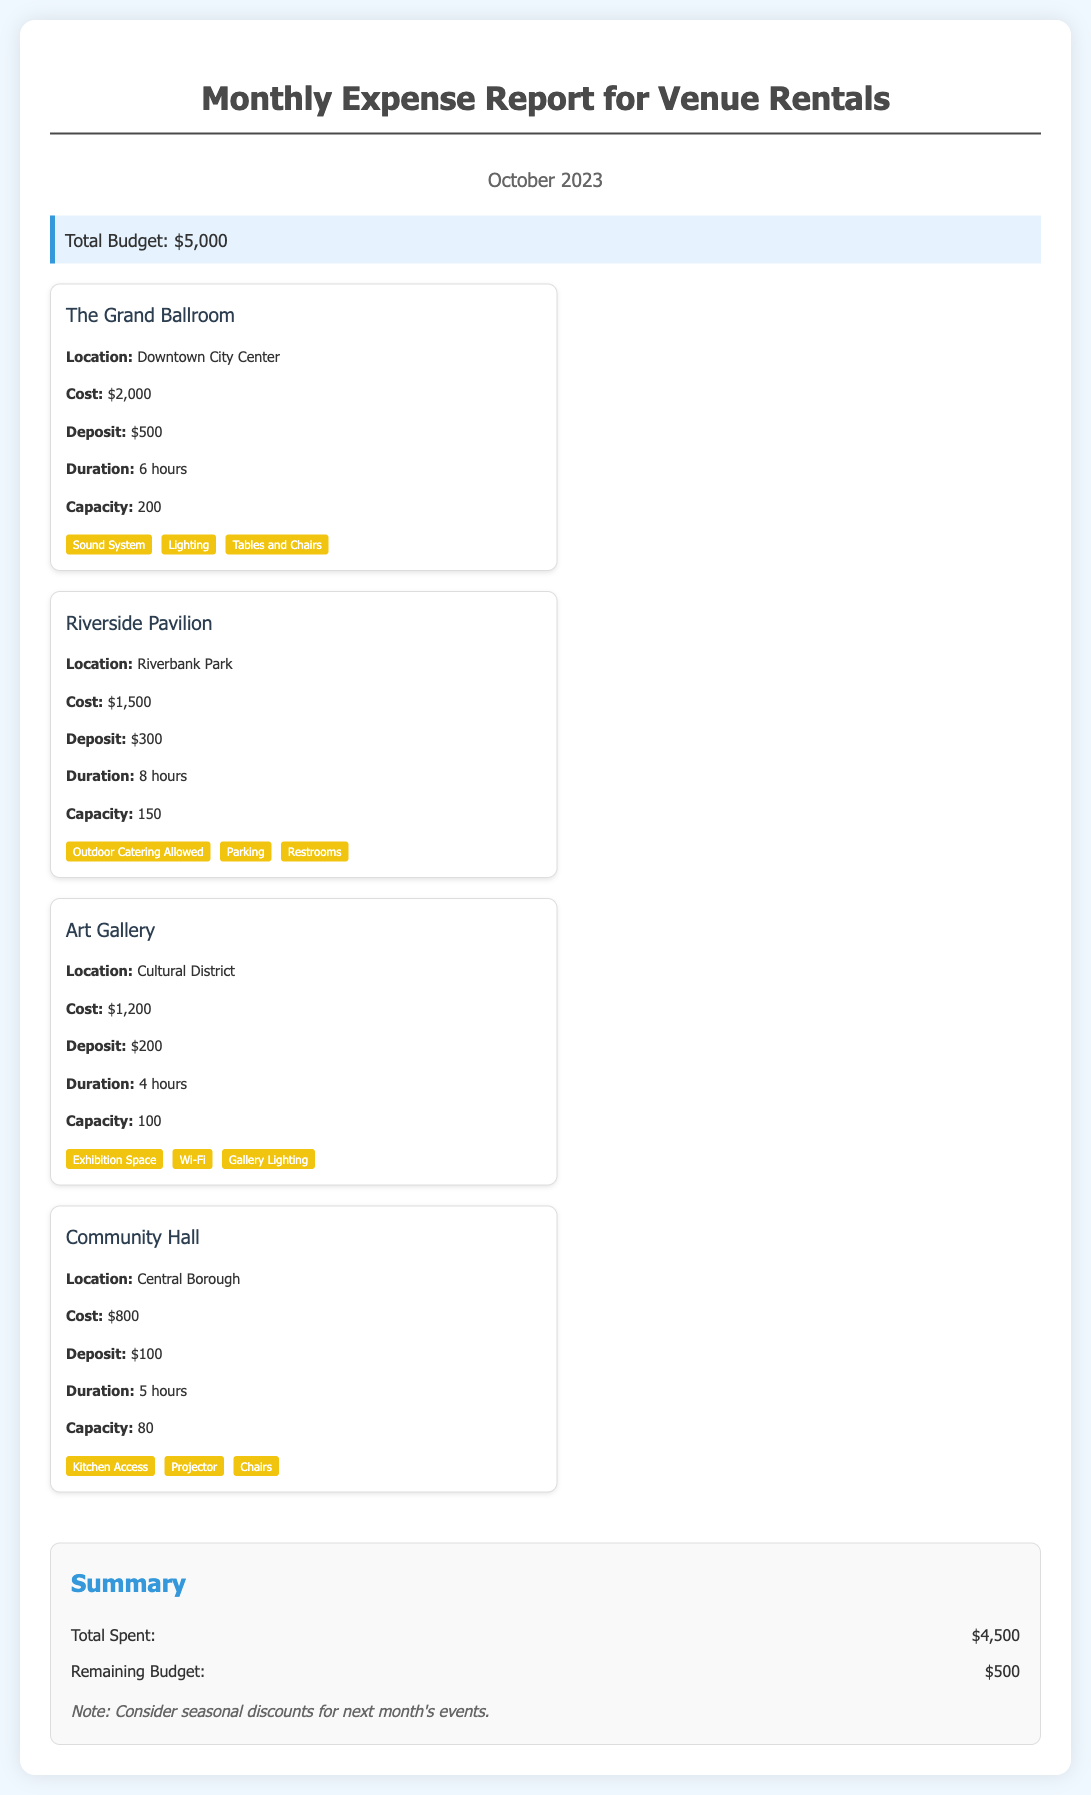What is the total budget? The total budget is explicitly stated in the document and is listed as $5,000.
Answer: $5,000 What is the cost of The Grand Ballroom? The Grand Ballroom's cost is detailed in the venue information, which is $2,000.
Answer: $2,000 How many hours can you rent the Riverside Pavilion? The duration for renting the Riverside Pavilion is mentioned in the venue details, which is 8 hours.
Answer: 8 hours What amenities are available at the Art Gallery? Amenities are listed for the Art Gallery, including Exhibition Space, Wi-Fi, and Gallery Lighting.
Answer: Exhibition Space, Wi-Fi, Gallery Lighting What is the total amount spent on venues? The total spent is summarized at the bottom of the document and is listed as $4,500.
Answer: $4,500 Which venue has the highest capacity? The venue capacity for each location is provided, and The Grand Ballroom has the highest capacity of 200.
Answer: 200 What is the remaining budget after expenses? The remaining budget is included in the summary section, which states $500 is left.
Answer: $500 What deposit is required for the Community Hall? The deposit for the Community Hall is indicated in the document as $100.
Answer: $100 How many venues are listed in the report? The number of venue cards presented in the document gives a clear count of venues, which is four.
Answer: Four 